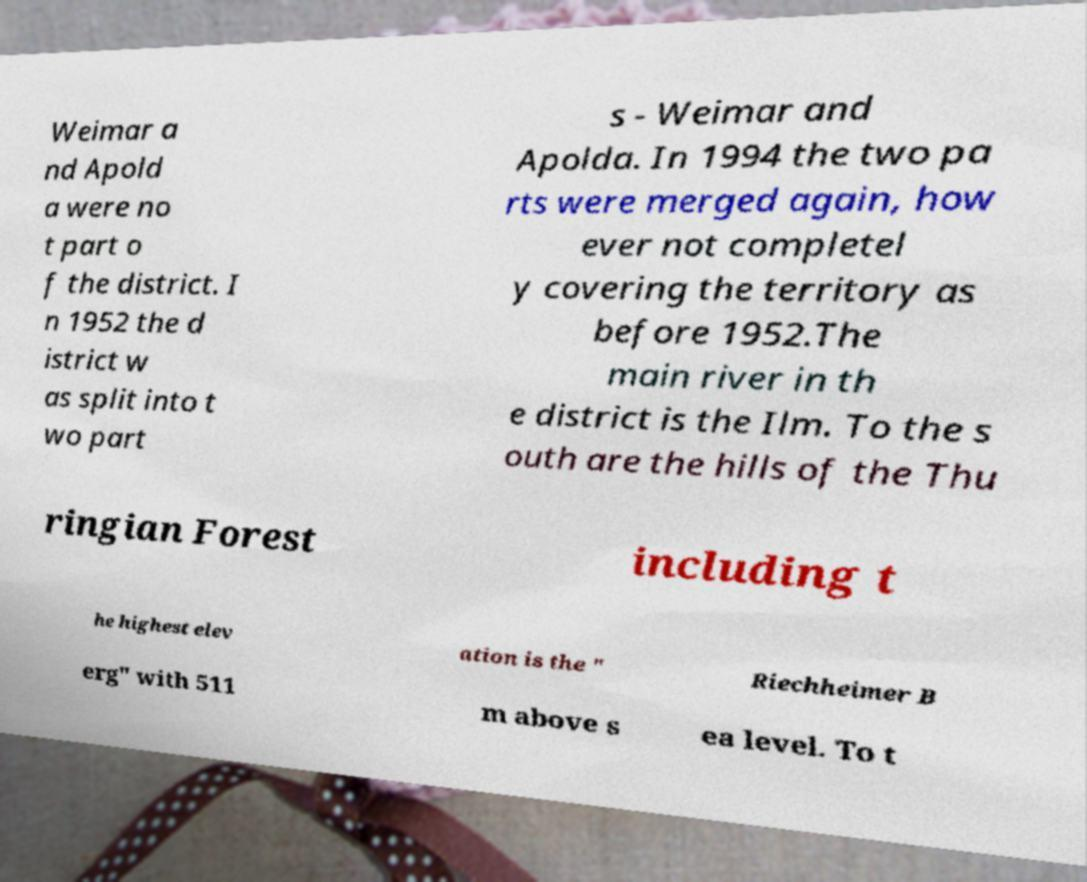Could you assist in decoding the text presented in this image and type it out clearly? Weimar a nd Apold a were no t part o f the district. I n 1952 the d istrict w as split into t wo part s - Weimar and Apolda. In 1994 the two pa rts were merged again, how ever not completel y covering the territory as before 1952.The main river in th e district is the Ilm. To the s outh are the hills of the Thu ringian Forest including t he highest elev ation is the " Riechheimer B erg" with 511 m above s ea level. To t 